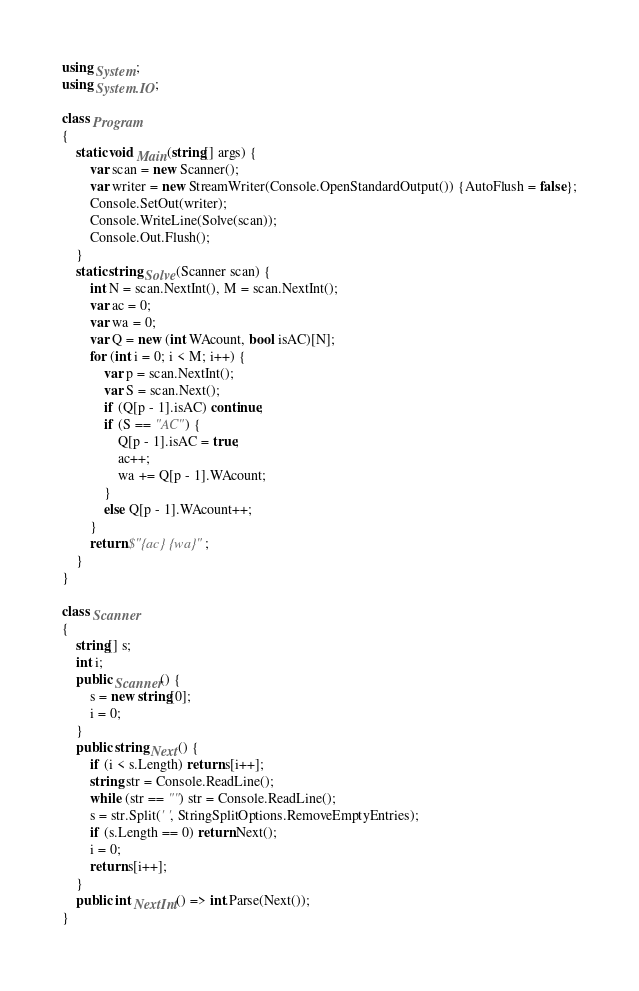Convert code to text. <code><loc_0><loc_0><loc_500><loc_500><_C#_>using System;
using System.IO;

class Program
{
    static void Main(string[] args) {
        var scan = new Scanner();
        var writer = new StreamWriter(Console.OpenStandardOutput()) {AutoFlush = false};
        Console.SetOut(writer);
        Console.WriteLine(Solve(scan));
        Console.Out.Flush();
    }
    static string Solve(Scanner scan) {
        int N = scan.NextInt(), M = scan.NextInt();
        var ac = 0;
        var wa = 0;
        var Q = new (int WAcount, bool isAC)[N];
        for (int i = 0; i < M; i++) {
            var p = scan.NextInt();
            var S = scan.Next();
            if (Q[p - 1].isAC) continue;
            if (S == "AC") {
                Q[p - 1].isAC = true;
                ac++;
                wa += Q[p - 1].WAcount;
            }
            else Q[p - 1].WAcount++;
        }
        return $"{ac} {wa}";
    }
}

class Scanner
{
    string[] s;
    int i;
    public Scanner() {
        s = new string[0];
        i = 0;
    }
    public string Next() {
        if (i < s.Length) return s[i++];
        string str = Console.ReadLine();
        while (str == "") str = Console.ReadLine();
        s = str.Split(' ', StringSplitOptions.RemoveEmptyEntries);
        if (s.Length == 0) return Next();
        i = 0;
        return s[i++];
    }
    public int NextInt() => int.Parse(Next());
}</code> 